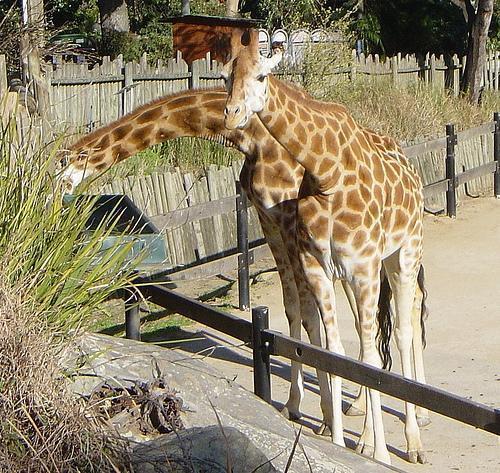How many giraffes are there?
Give a very brief answer. 2. 